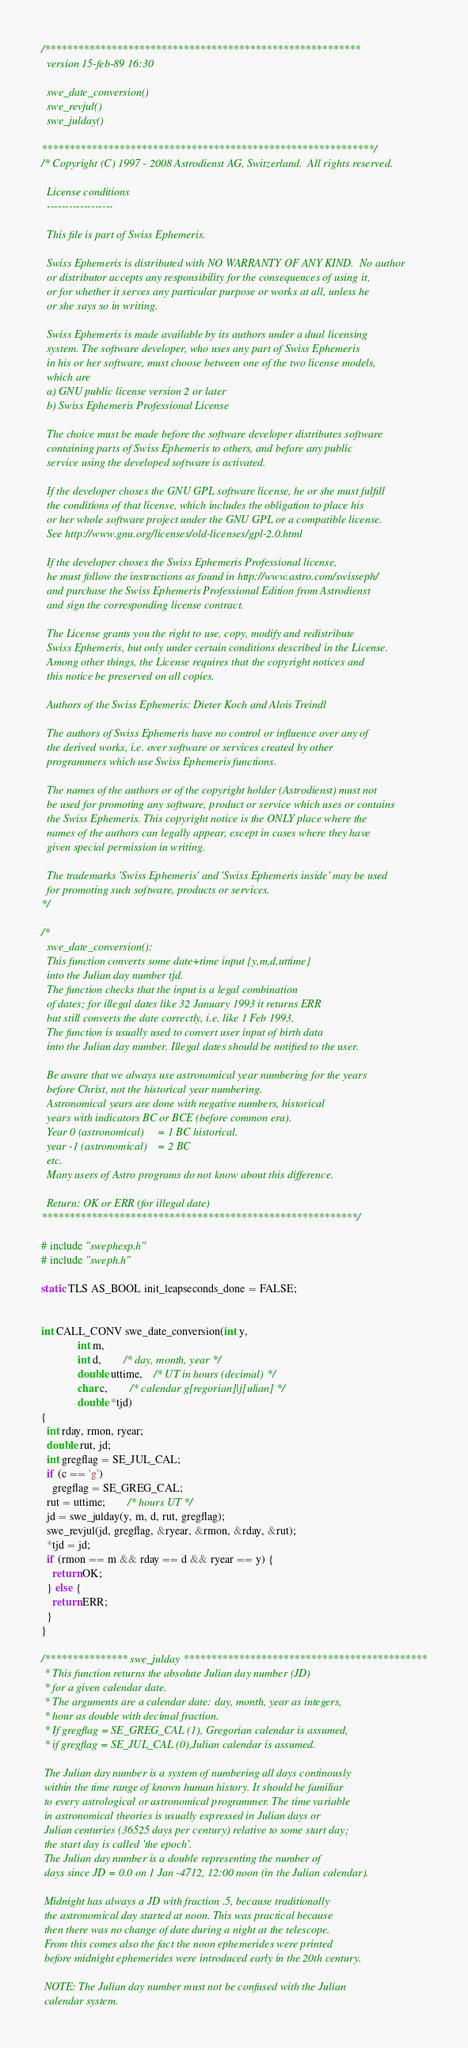Convert code to text. <code><loc_0><loc_0><loc_500><loc_500><_C_>/*********************************************************
  version 15-feb-89 16:30
  
  swe_date_conversion()
  swe_revjul()
  swe_julday()

************************************************************/
/* Copyright (C) 1997 - 2008 Astrodienst AG, Switzerland.  All rights reserved.
  
  License conditions
  ------------------

  This file is part of Swiss Ephemeris.
  
  Swiss Ephemeris is distributed with NO WARRANTY OF ANY KIND.  No author
  or distributor accepts any responsibility for the consequences of using it,
  or for whether it serves any particular purpose or works at all, unless he
  or she says so in writing.  

  Swiss Ephemeris is made available by its authors under a dual licensing
  system. The software developer, who uses any part of Swiss Ephemeris
  in his or her software, must choose between one of the two license models,
  which are
  a) GNU public license version 2 or later
  b) Swiss Ephemeris Professional License
  
  The choice must be made before the software developer distributes software
  containing parts of Swiss Ephemeris to others, and before any public
  service using the developed software is activated.

  If the developer choses the GNU GPL software license, he or she must fulfill
  the conditions of that license, which includes the obligation to place his
  or her whole software project under the GNU GPL or a compatible license.
  See http://www.gnu.org/licenses/old-licenses/gpl-2.0.html

  If the developer choses the Swiss Ephemeris Professional license,
  he must follow the instructions as found in http://www.astro.com/swisseph/ 
  and purchase the Swiss Ephemeris Professional Edition from Astrodienst
  and sign the corresponding license contract.

  The License grants you the right to use, copy, modify and redistribute
  Swiss Ephemeris, but only under certain conditions described in the License.
  Among other things, the License requires that the copyright notices and
  this notice be preserved on all copies.

  Authors of the Swiss Ephemeris: Dieter Koch and Alois Treindl

  The authors of Swiss Ephemeris have no control or influence over any of
  the derived works, i.e. over software or services created by other
  programmers which use Swiss Ephemeris functions.

  The names of the authors or of the copyright holder (Astrodienst) must not
  be used for promoting any software, product or service which uses or contains
  the Swiss Ephemeris. This copyright notice is the ONLY place where the
  names of the authors can legally appear, except in cases where they have
  given special permission in writing.

  The trademarks 'Swiss Ephemeris' and 'Swiss Ephemeris inside' may be used
  for promoting such software, products or services.
*/

/*
  swe_date_conversion():
  This function converts some date+time input {y,m,d,uttime}
  into the Julian day number tjd.
  The function checks that the input is a legal combination
  of dates; for illegal dates like 32 January 1993 it returns ERR
  but still converts the date correctly, i.e. like 1 Feb 1993.
  The function is usually used to convert user input of birth data
  into the Julian day number. Illegal dates should be notified to the user.

  Be aware that we always use astronomical year numbering for the years
  before Christ, not the historical year numbering.
  Astronomical years are done with negative numbers, historical
  years with indicators BC or BCE (before common era).
  Year 0 (astronomical)  	= 1 BC historical.
  year -1 (astronomical) 	= 2 BC
  etc.
  Many users of Astro programs do not know about this difference.

  Return: OK or ERR (for illegal date)
*********************************************************/

# include "swephexp.h"
# include "sweph.h"

static TLS AS_BOOL init_leapseconds_done = FALSE;


int CALL_CONV swe_date_conversion(int y,
		     int m,
		     int d,		/* day, month, year */
		     double uttime, 	/* UT in hours (decimal) */
		     char c,		/* calendar g[regorian]|j[ulian] */
		     double *tjd)
{
  int rday, rmon, ryear;
  double rut, jd;
  int gregflag = SE_JUL_CAL;
  if (c == 'g')
    gregflag = SE_GREG_CAL;
  rut = uttime;		/* hours UT */
  jd = swe_julday(y, m, d, rut, gregflag);
  swe_revjul(jd, gregflag, &ryear, &rmon, &rday, &rut);
  *tjd = jd;
  if (rmon == m && rday == d && ryear == y) {
    return OK;
  } else {
    return ERR;
  }
}

/*************** swe_julday ********************************************
 * This function returns the absolute Julian day number (JD)
 * for a given calendar date.
 * The arguments are a calendar date: day, month, year as integers,
 * hour as double with decimal fraction.
 * If gregflag = SE_GREG_CAL (1), Gregorian calendar is assumed,
 * if gregflag = SE_JUL_CAL (0),Julian calendar is assumed.
  
 The Julian day number is a system of numbering all days continously
 within the time range of known human history. It should be familiar
 to every astrological or astronomical programmer. The time variable
 in astronomical theories is usually expressed in Julian days or
 Julian centuries (36525 days per century) relative to some start day;
 the start day is called 'the epoch'.
 The Julian day number is a double representing the number of
 days since JD = 0.0 on 1 Jan -4712, 12:00 noon (in the Julian calendar).
 
 Midnight has always a JD with fraction .5, because traditionally
 the astronomical day started at noon. This was practical because
 then there was no change of date during a night at the telescope.
 From this comes also the fact the noon ephemerides were printed
 before midnight ephemerides were introduced early in the 20th century.
 
 NOTE: The Julian day number must not be confused with the Julian 
 calendar system.
</code> 